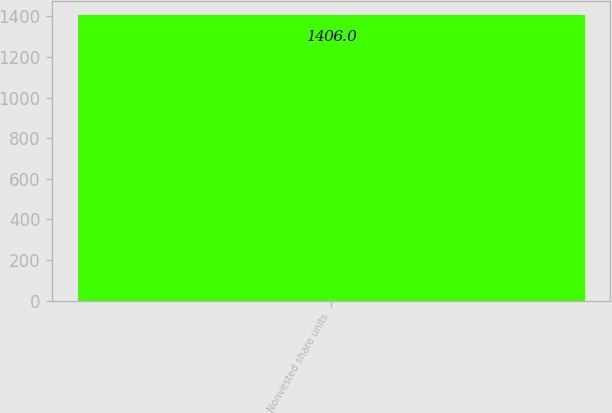Convert chart. <chart><loc_0><loc_0><loc_500><loc_500><bar_chart><fcel>Nonvested share units<nl><fcel>1406<nl></chart> 